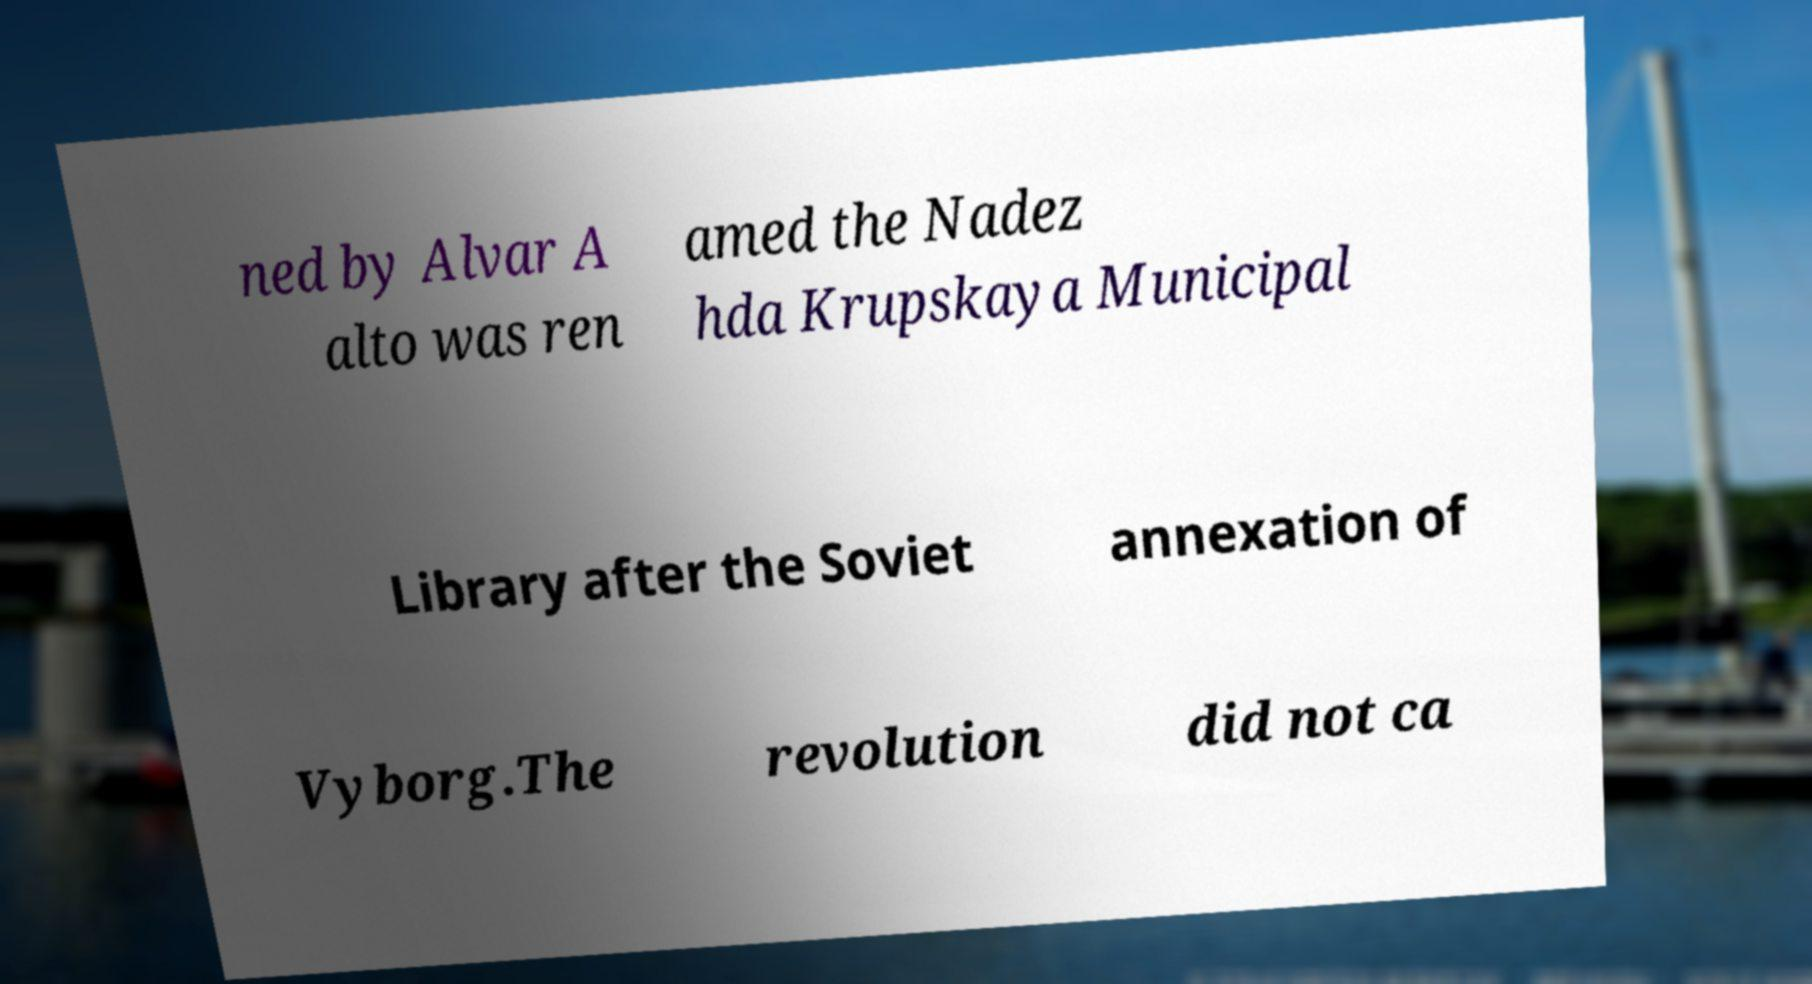For documentation purposes, I need the text within this image transcribed. Could you provide that? ned by Alvar A alto was ren amed the Nadez hda Krupskaya Municipal Library after the Soviet annexation of Vyborg.The revolution did not ca 